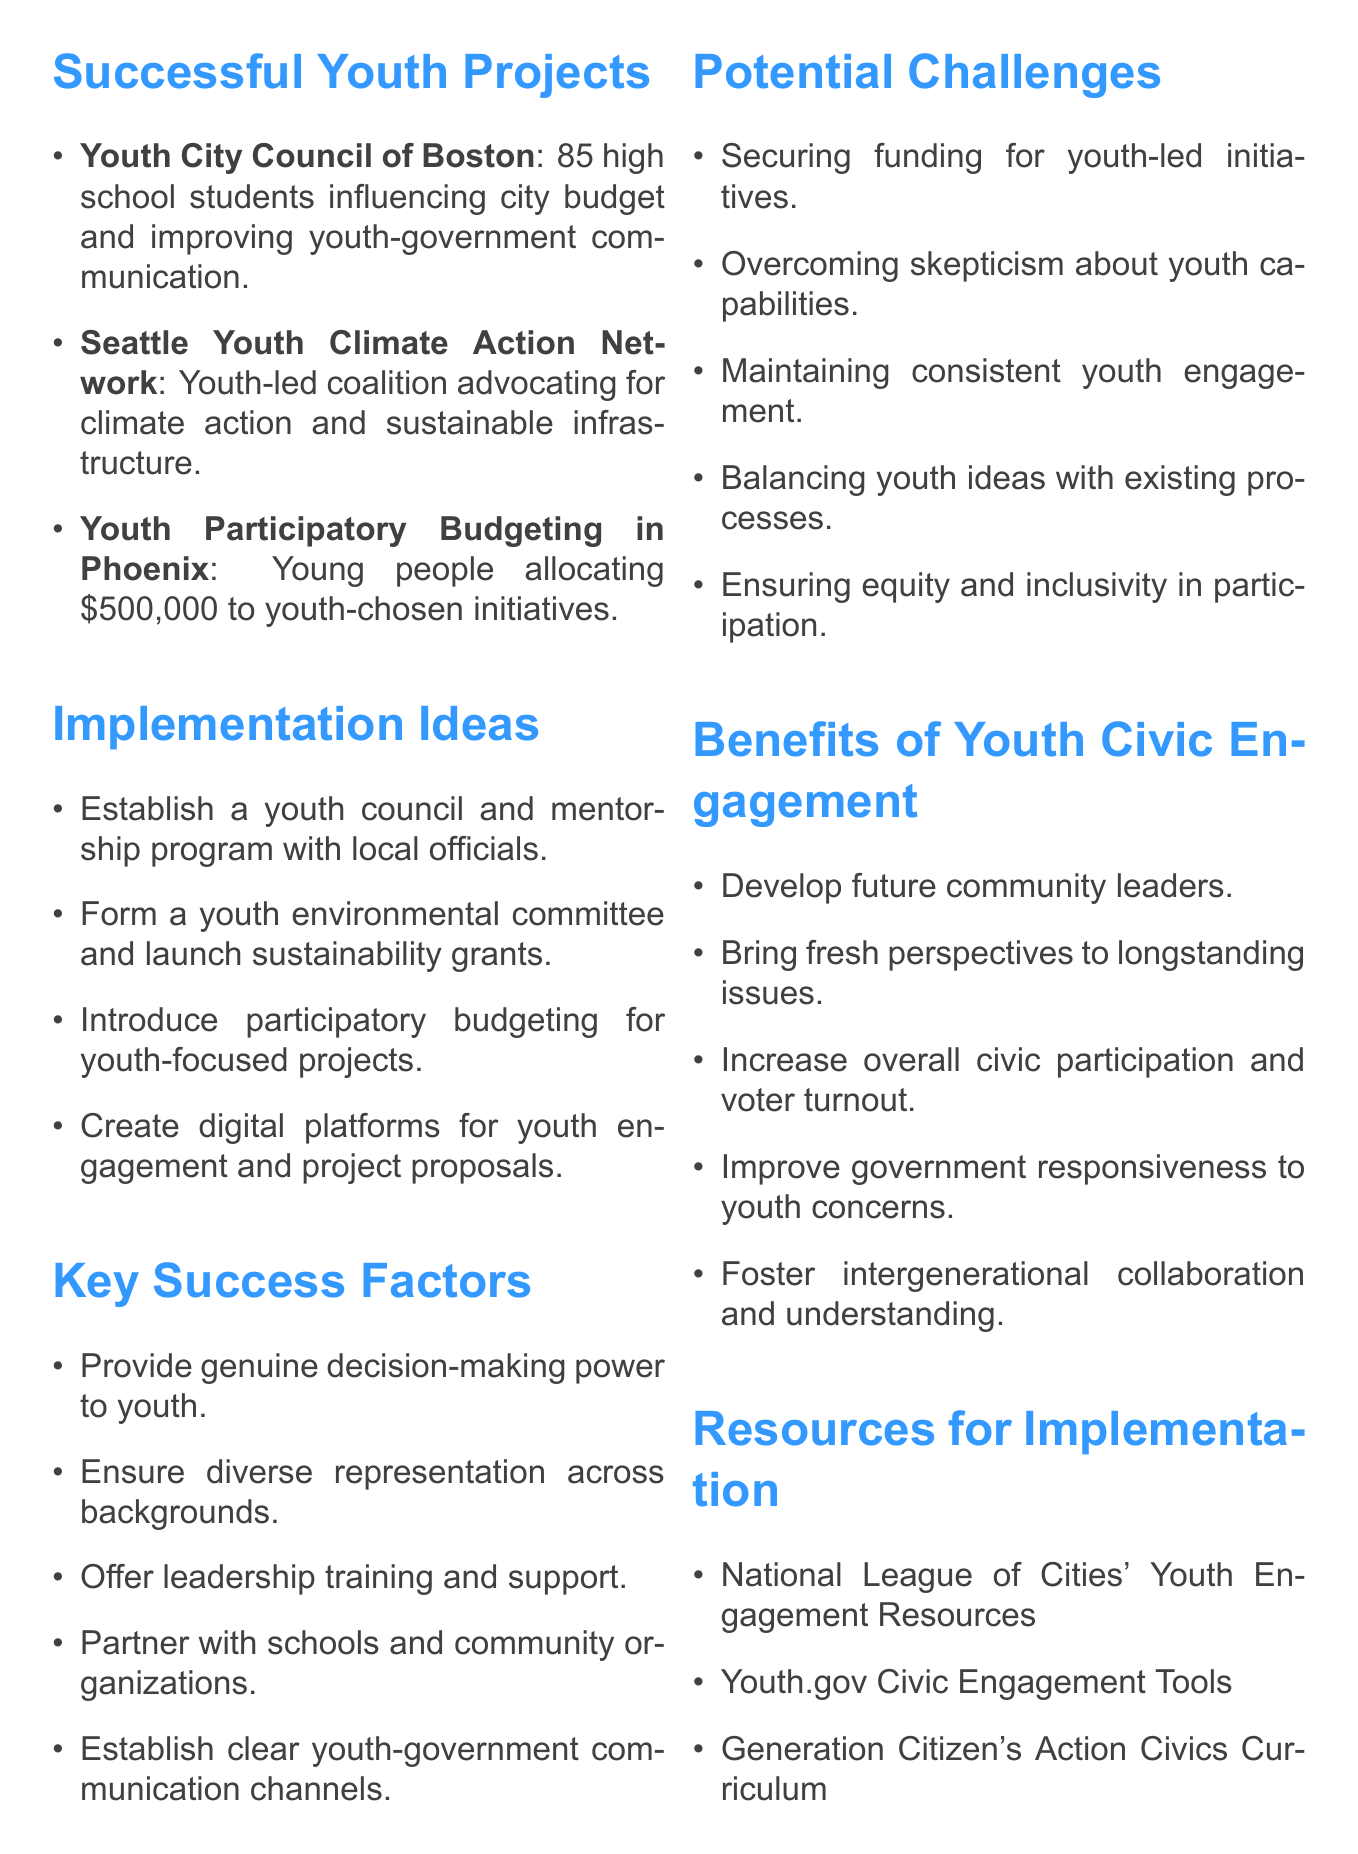What is the name of the youth project in Seattle? The document states that the project is called the Seattle Youth Climate Action Network.
Answer: Seattle Youth Climate Action Network How many members are in the Youth City Council of Boston? According to the document, there are 85 high school-aged youth in the council.
Answer: 85 What dollar amount was allocated by the Youth Participatory Budgeting in Phoenix? The document specifies that the program allocated $500,000 to youth-chosen initiatives.
Answer: $500,000 What is one key success factor mentioned in the document? The document lists several key success factors, one being providing genuine decision-making power to youth participants.
Answer: Providing genuine decision-making power to youth participants What is a potential challenge for youth-led initiatives according to the document? One potential challenge mentioned is securing funding for youth-led initiatives.
Answer: Securing funding for youth-led initiatives What type of committee could be formed as an implementation idea in our district? The document suggests forming a youth environmental advisory committee.
Answer: Youth environmental advisory committee What is one resource for implementation provided in the document? The document mentions the National League of Cities' Youth Engagement Resources.
Answer: National League of Cities' Youth Engagement Resources What is a benefit of youth civic engagement listed in the document? The document states that developing future community leaders is a benefit of youth civic engagement.
Answer: Developing future community leaders 